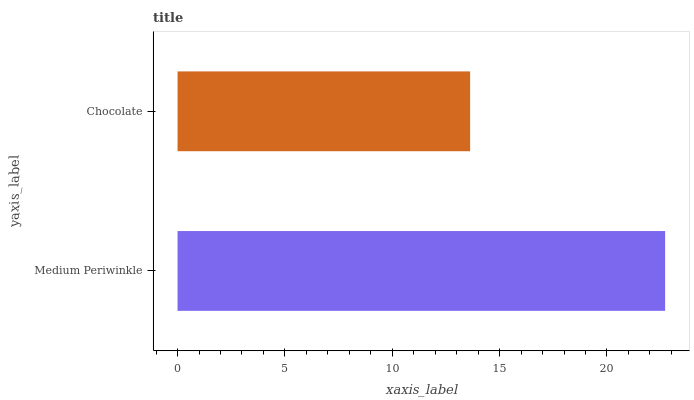Is Chocolate the minimum?
Answer yes or no. Yes. Is Medium Periwinkle the maximum?
Answer yes or no. Yes. Is Chocolate the maximum?
Answer yes or no. No. Is Medium Periwinkle greater than Chocolate?
Answer yes or no. Yes. Is Chocolate less than Medium Periwinkle?
Answer yes or no. Yes. Is Chocolate greater than Medium Periwinkle?
Answer yes or no. No. Is Medium Periwinkle less than Chocolate?
Answer yes or no. No. Is Medium Periwinkle the high median?
Answer yes or no. Yes. Is Chocolate the low median?
Answer yes or no. Yes. Is Chocolate the high median?
Answer yes or no. No. Is Medium Periwinkle the low median?
Answer yes or no. No. 